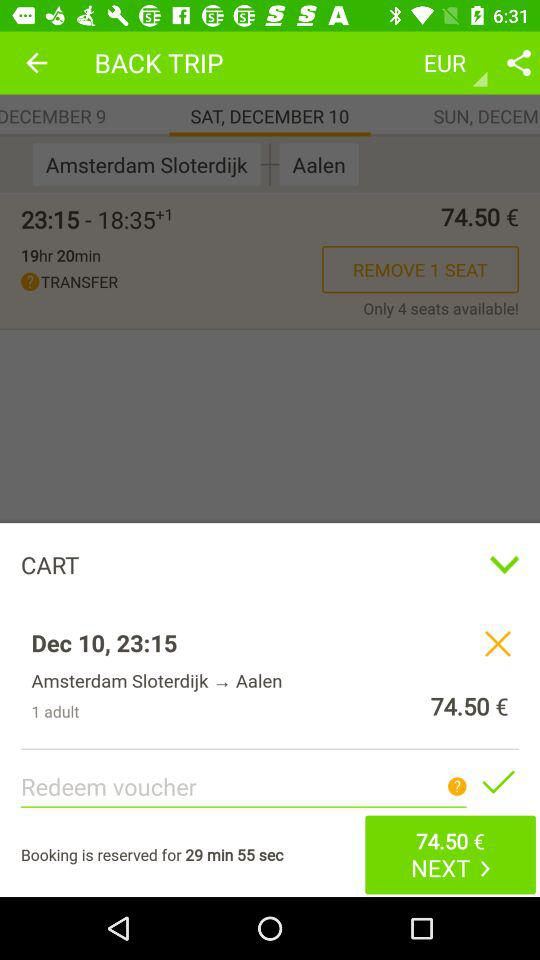How many seats are available?
Answer the question using a single word or phrase. 4 